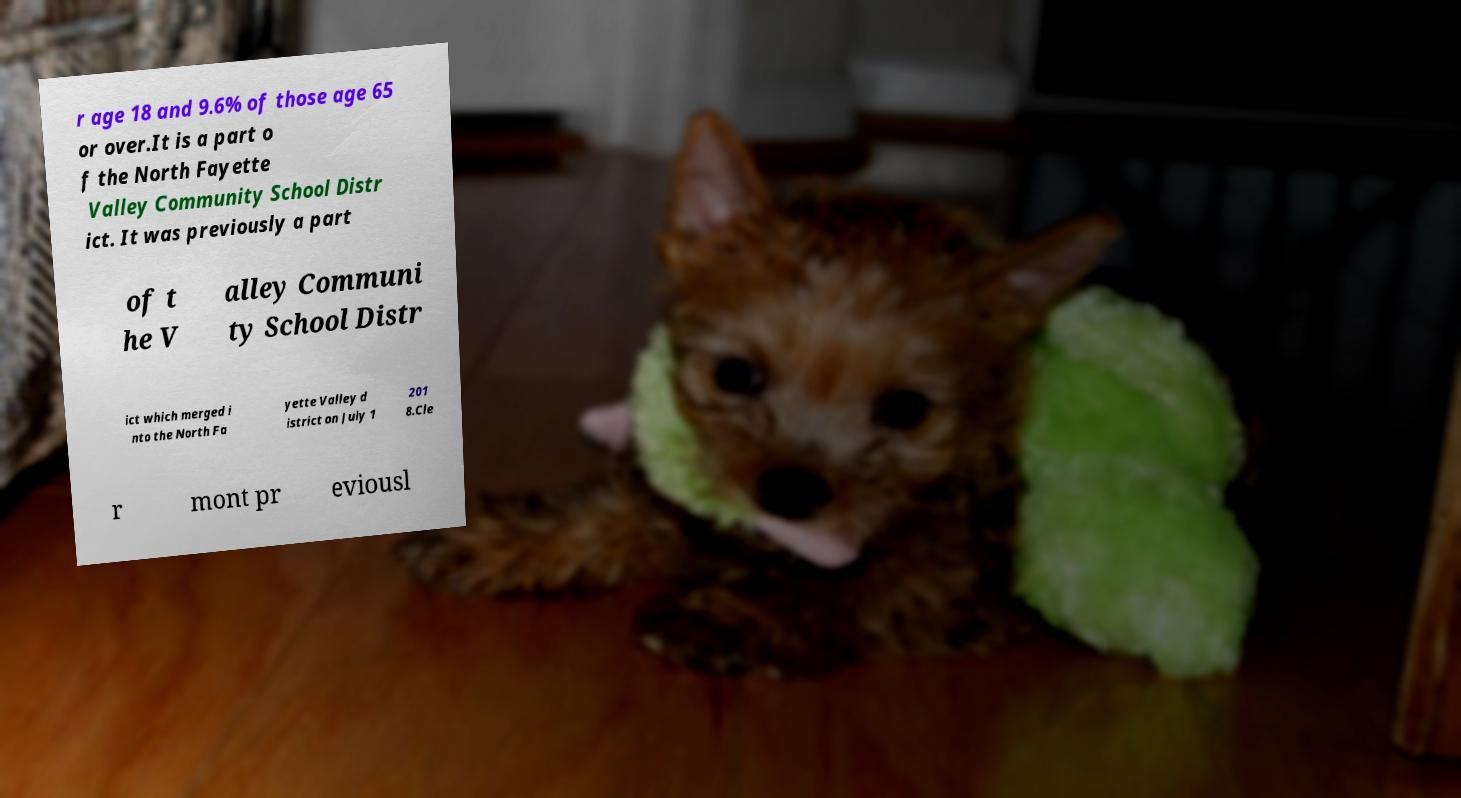Please read and relay the text visible in this image. What does it say? r age 18 and 9.6% of those age 65 or over.It is a part o f the North Fayette Valley Community School Distr ict. It was previously a part of t he V alley Communi ty School Distr ict which merged i nto the North Fa yette Valley d istrict on July 1 201 8.Cle r mont pr eviousl 